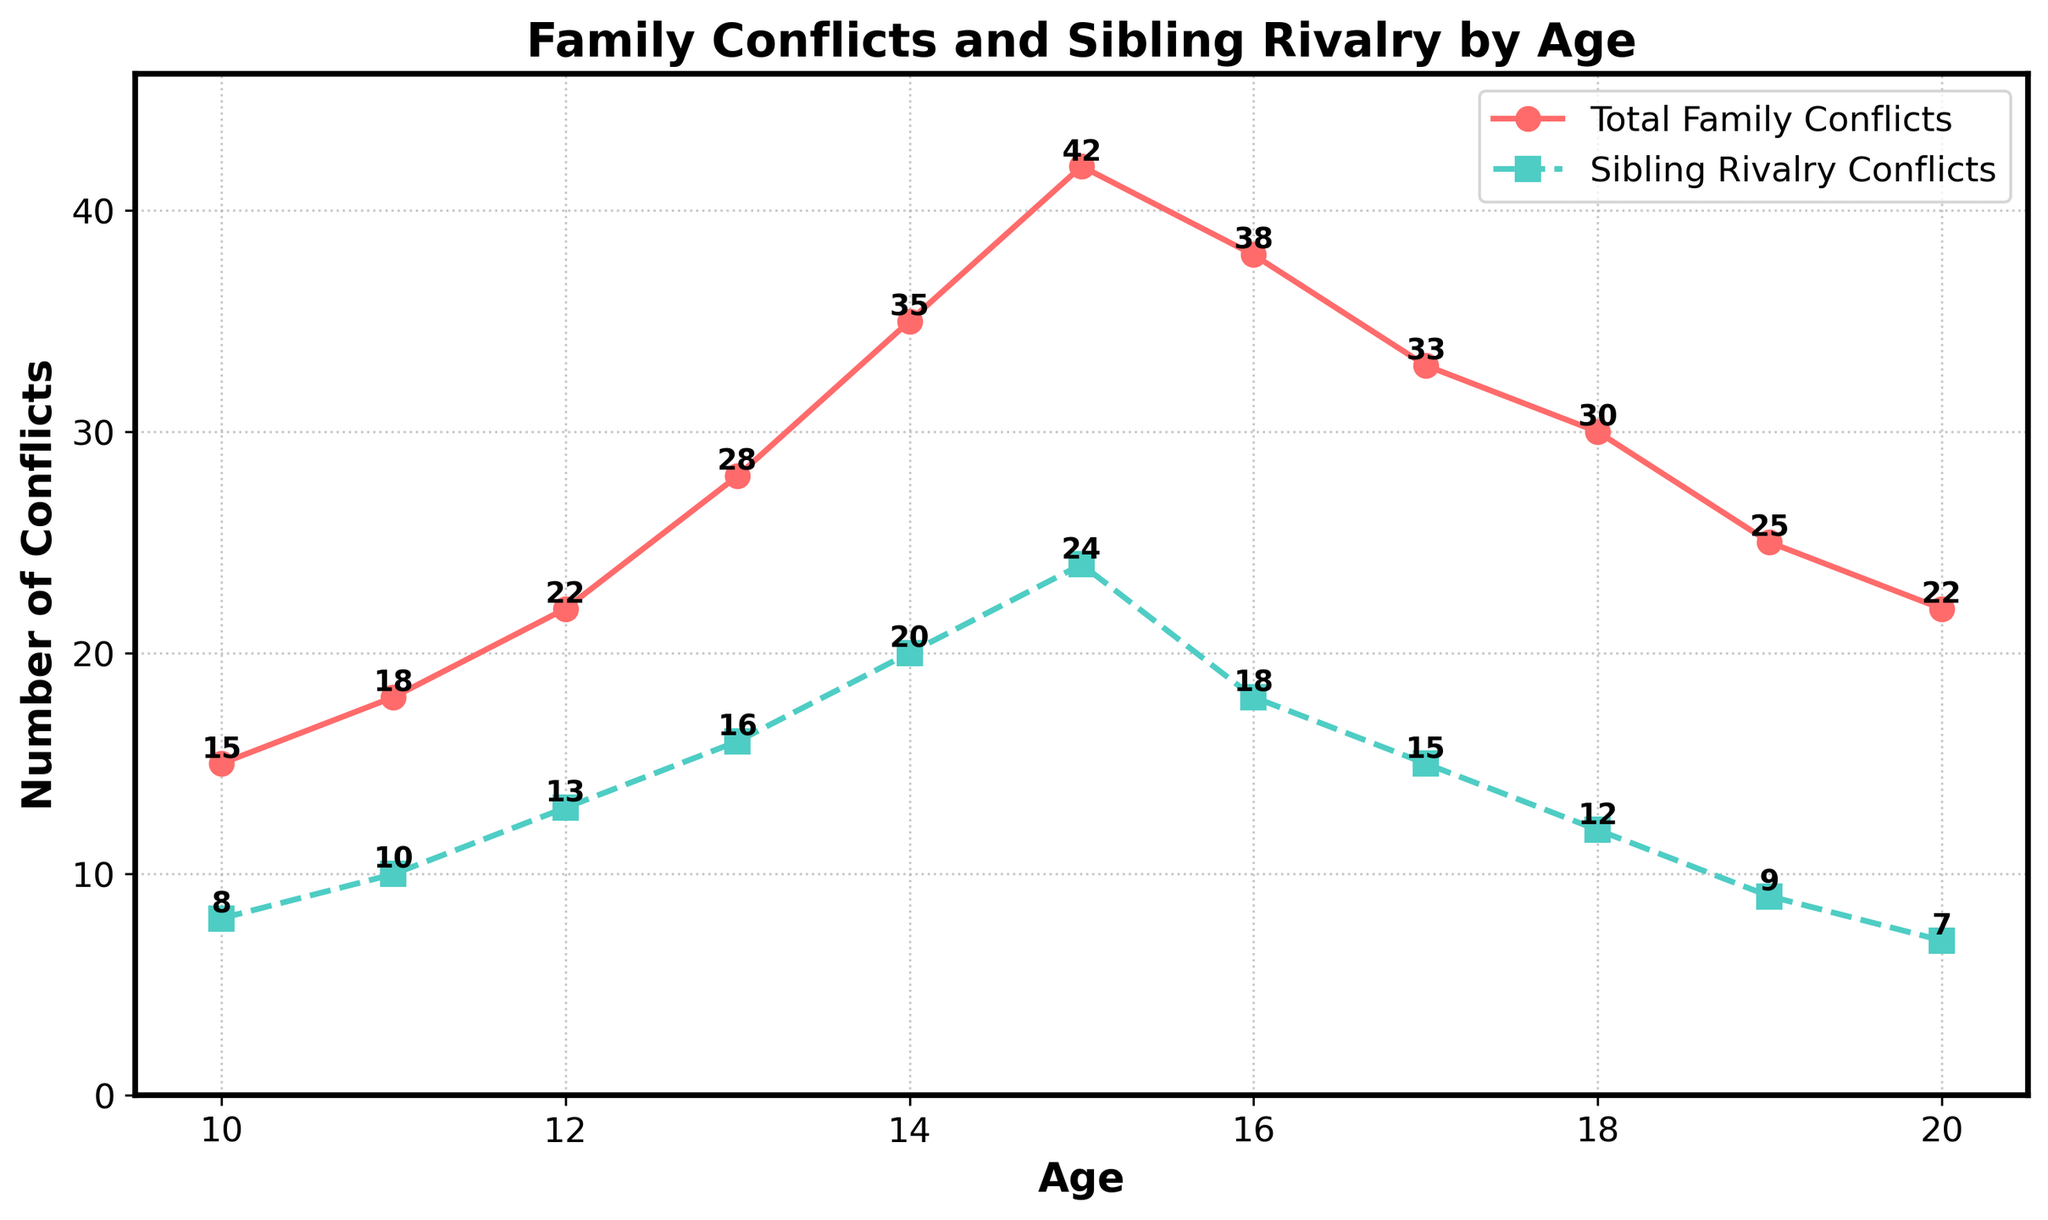What age has the highest total family conflicts? To find the highest total family conflicts, we look for the peak point in the red line (Total Family Conflicts) on the chart. The peak occurs at age 15 with a value of 42.
Answer: 15 What's the difference between total family conflicts and sibling rivalry conflicts at age 14? First, find the values at age 14: Total Family Conflicts is 35, and Sibling Rivalry Conflicts is 20. The difference is 35 - 20 = 15.
Answer: 15 At which age does sibling rivalry conflict peak? We look for the highest point on the green line (Sibling Rivalry Conflicts) and find that it peaks at age 15 with a value of 24.
Answer: 15 Compare the total family conflicts at age 13 and age 17. Which one is higher? The total family conflicts at age 13 are 28, and at age 17 it is 33. Comparing the two values, age 17 has the higher total family conflicts.
Answer: 17 What's the average number of sibling rivalry conflicts between ages 10 and 20? Sum the sibling rivalry conflicts: 8 + 10 + 13 + 16 + 20 + 24 + 18 + 15 + 12 + 9 + 7 = 152. There are 11 ages in total. The average is 152 / 11 = approx. 13.82.
Answer: 13.82 By how much do total family conflicts decrease from age 15 to age 20? Total family conflicts at age 15 are 42, and at age 20 it is 22. The decrease is 42 - 22 = 20.
Answer: 20 Which color line represents sibling rivalry conflicts? To identify, look at the legend or the line style: the sibling rivalry conflicts are shown with a green dashed line.
Answer: Green What is the lowest value of sibling rivalry conflicts shown on the chart? We find the lowest point on the green line (Sibling Rivalry Conflicts) which is at age 20 with a value of 7.
Answer: 7 How do total family conflicts and sibling rivalry conflicts compare at age 18? At age 18, total family conflicts are 30, and sibling rivalry conflicts are 12. Total family conflicts are higher than sibling rivalry conflicts.
Answer: Total family conflicts are higher Is there any age where total family conflicts and sibling rivalry conflicts are equal? By checking each data point, there is no age where the values of total family conflicts and sibling rivalry conflicts are equal.
Answer: No 